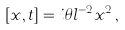<formula> <loc_0><loc_0><loc_500><loc_500>[ x , t ] = i \theta l ^ { - 2 } x ^ { 2 } \, ,</formula> 